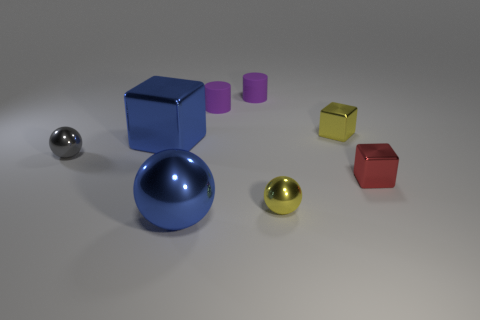Do the red metal thing and the yellow block have the same size?
Offer a terse response. Yes. What is the color of the metallic thing that is both on the left side of the big shiny sphere and in front of the big metallic cube?
Your answer should be compact. Gray. What number of other small gray objects are made of the same material as the small gray object?
Offer a very short reply. 0. How many big rubber things are there?
Your answer should be very brief. 0. Is the size of the gray thing the same as the yellow object in front of the red thing?
Keep it short and to the point. Yes. There is a small gray object that is left of the tiny block in front of the tiny yellow cube; what is its material?
Offer a terse response. Metal. There is a metal object on the left side of the block on the left side of the tiny yellow object to the left of the yellow shiny cube; what size is it?
Provide a succinct answer. Small. There is a red metallic object; does it have the same shape as the large blue shiny thing that is left of the blue metal sphere?
Keep it short and to the point. Yes. What is the material of the yellow sphere?
Your response must be concise. Metal. What number of matte things are big green things or blue blocks?
Ensure brevity in your answer.  0. 